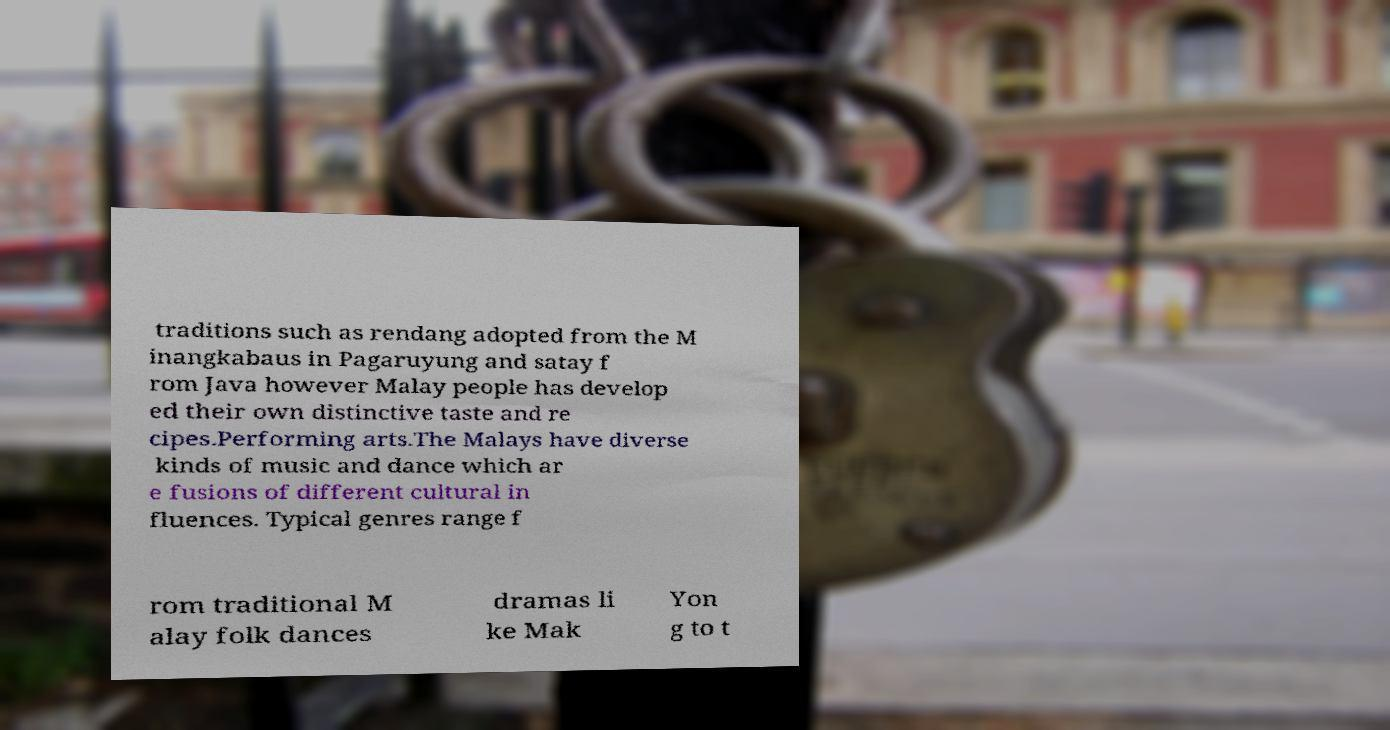For documentation purposes, I need the text within this image transcribed. Could you provide that? traditions such as rendang adopted from the M inangkabaus in Pagaruyung and satay f rom Java however Malay people has develop ed their own distinctive taste and re cipes.Performing arts.The Malays have diverse kinds of music and dance which ar e fusions of different cultural in fluences. Typical genres range f rom traditional M alay folk dances dramas li ke Mak Yon g to t 